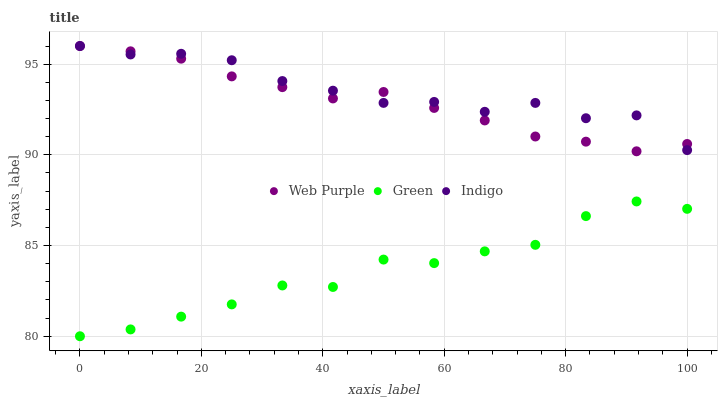Does Green have the minimum area under the curve?
Answer yes or no. Yes. Does Indigo have the maximum area under the curve?
Answer yes or no. Yes. Does Web Purple have the minimum area under the curve?
Answer yes or no. No. Does Web Purple have the maximum area under the curve?
Answer yes or no. No. Is Web Purple the smoothest?
Answer yes or no. Yes. Is Green the roughest?
Answer yes or no. Yes. Is Green the smoothest?
Answer yes or no. No. Is Web Purple the roughest?
Answer yes or no. No. Does Green have the lowest value?
Answer yes or no. Yes. Does Web Purple have the lowest value?
Answer yes or no. No. Does Web Purple have the highest value?
Answer yes or no. Yes. Does Green have the highest value?
Answer yes or no. No. Is Green less than Indigo?
Answer yes or no. Yes. Is Web Purple greater than Green?
Answer yes or no. Yes. Does Indigo intersect Web Purple?
Answer yes or no. Yes. Is Indigo less than Web Purple?
Answer yes or no. No. Is Indigo greater than Web Purple?
Answer yes or no. No. Does Green intersect Indigo?
Answer yes or no. No. 